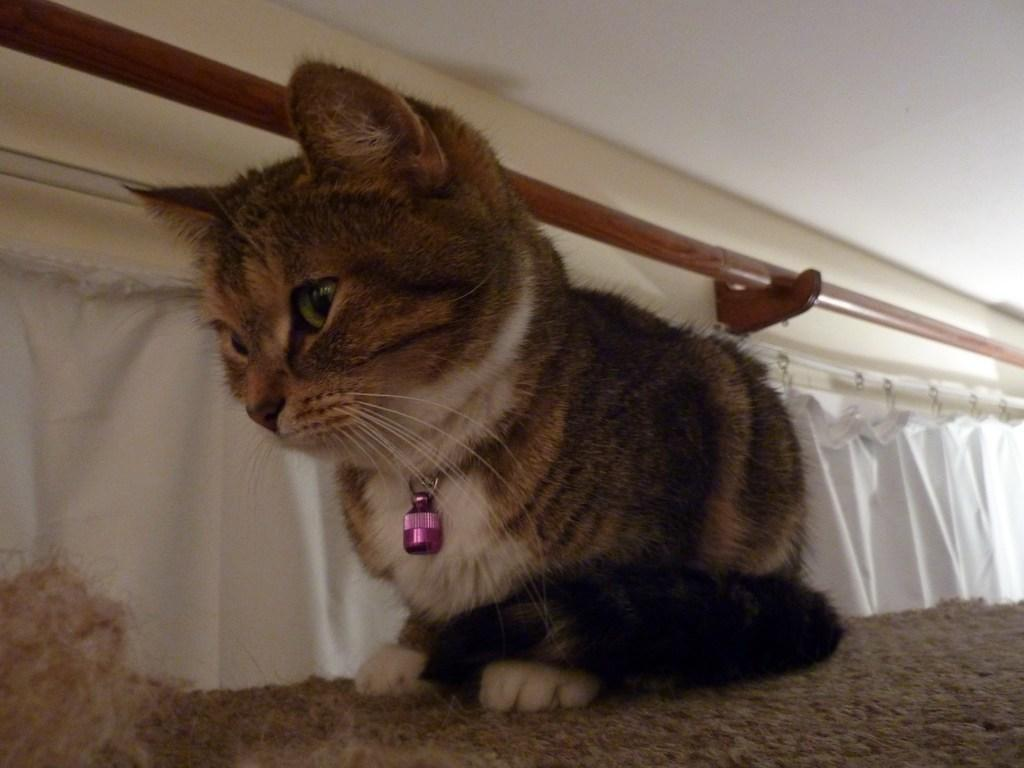What type of animal can be seen in the image? There is a cat in the image. What color is the cloth visible in the image? The cloth in the image is white. What is the background of the image? There is a wall in the image. What type of produce can be seen in the image? There is no produce present in the image; it features a cat and a white cloth. What type of food is the cat eating in the image? There is no food visible in the image, and the cat's actions are not described. 